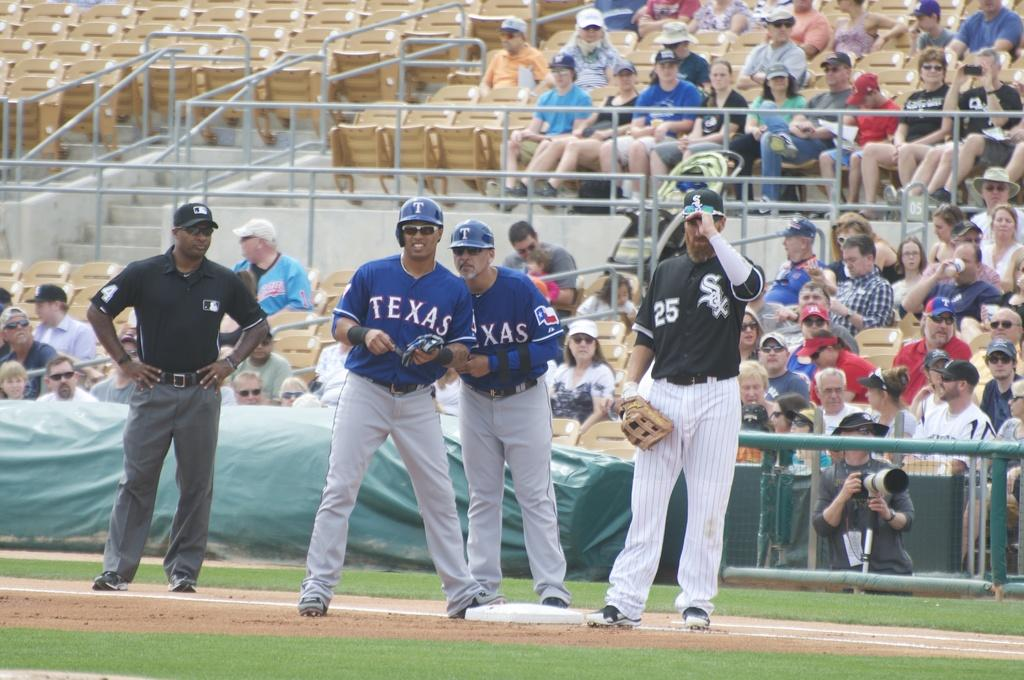<image>
Offer a succinct explanation of the picture presented. Two Texas teammates wearing sunglasses talk at the base. 